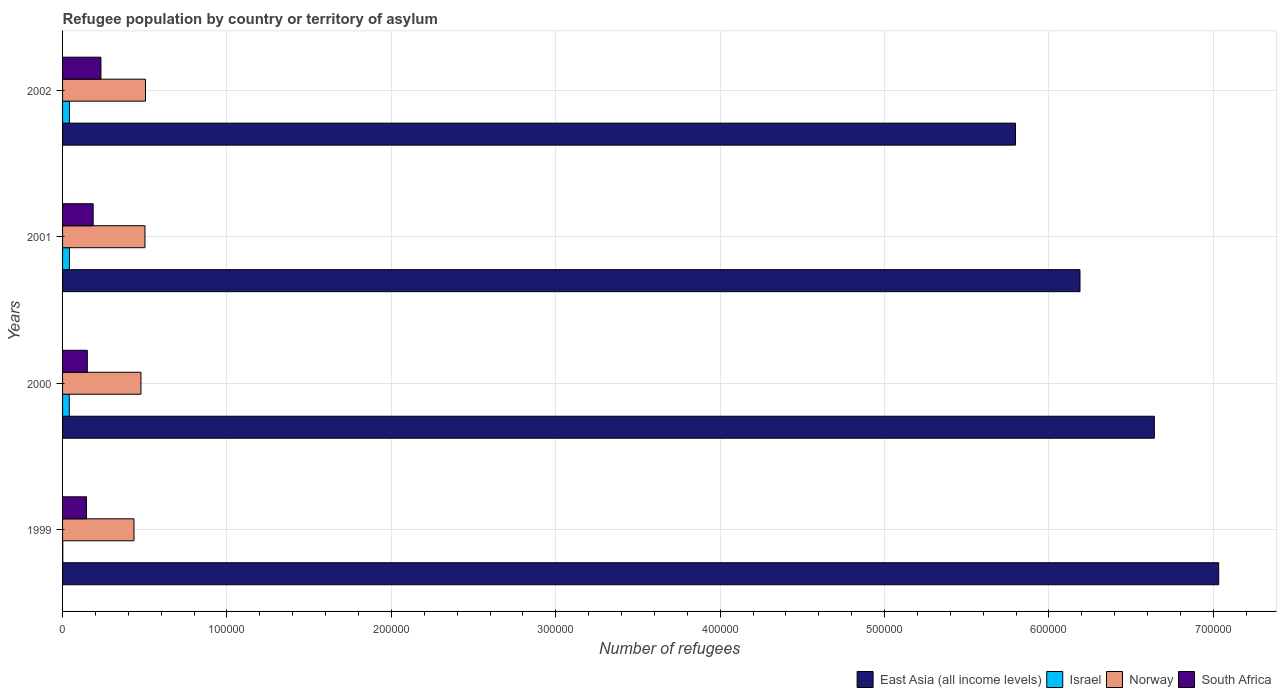How many different coloured bars are there?
Offer a terse response. 4. Are the number of bars per tick equal to the number of legend labels?
Your response must be concise. Yes. Are the number of bars on each tick of the Y-axis equal?
Provide a short and direct response. Yes. How many bars are there on the 1st tick from the top?
Keep it short and to the point. 4. How many bars are there on the 3rd tick from the bottom?
Provide a short and direct response. 4. What is the number of refugees in South Africa in 2000?
Your answer should be very brief. 1.51e+04. Across all years, what is the maximum number of refugees in Norway?
Provide a short and direct response. 5.04e+04. Across all years, what is the minimum number of refugees in East Asia (all income levels)?
Offer a terse response. 5.80e+05. In which year was the number of refugees in Norway maximum?
Ensure brevity in your answer.  2002. What is the total number of refugees in Israel in the graph?
Offer a very short reply. 1.26e+04. What is the difference between the number of refugees in South Africa in 1999 and that in 2001?
Make the answer very short. -4067. What is the difference between the number of refugees in South Africa in 2000 and the number of refugees in East Asia (all income levels) in 2001?
Offer a terse response. -6.04e+05. What is the average number of refugees in South Africa per year?
Your answer should be very brief. 1.79e+04. In the year 1999, what is the difference between the number of refugees in Israel and number of refugees in East Asia (all income levels)?
Your answer should be compact. -7.03e+05. What is the ratio of the number of refugees in Norway in 1999 to that in 2000?
Offer a terse response. 0.91. Is the difference between the number of refugees in Israel in 1999 and 2000 greater than the difference between the number of refugees in East Asia (all income levels) in 1999 and 2000?
Your answer should be compact. No. What is the difference between the highest and the second highest number of refugees in Norway?
Your answer should be very brief. 304. What is the difference between the highest and the lowest number of refugees in East Asia (all income levels)?
Provide a short and direct response. 1.24e+05. In how many years, is the number of refugees in Israel greater than the average number of refugees in Israel taken over all years?
Your answer should be compact. 3. What does the 4th bar from the top in 2001 represents?
Your answer should be compact. East Asia (all income levels). What does the 1st bar from the bottom in 1999 represents?
Keep it short and to the point. East Asia (all income levels). How many bars are there?
Provide a succinct answer. 16. How many years are there in the graph?
Give a very brief answer. 4. What is the difference between two consecutive major ticks on the X-axis?
Provide a succinct answer. 1.00e+05. Are the values on the major ticks of X-axis written in scientific E-notation?
Offer a terse response. No. Does the graph contain any zero values?
Make the answer very short. No. How are the legend labels stacked?
Offer a terse response. Horizontal. What is the title of the graph?
Provide a succinct answer. Refugee population by country or territory of asylum. Does "Syrian Arab Republic" appear as one of the legend labels in the graph?
Your response must be concise. No. What is the label or title of the X-axis?
Your answer should be very brief. Number of refugees. What is the label or title of the Y-axis?
Your answer should be very brief. Years. What is the Number of refugees in East Asia (all income levels) in 1999?
Offer a terse response. 7.03e+05. What is the Number of refugees in Israel in 1999?
Offer a very short reply. 128. What is the Number of refugees in Norway in 1999?
Offer a very short reply. 4.34e+04. What is the Number of refugees in South Africa in 1999?
Offer a very short reply. 1.45e+04. What is the Number of refugees of East Asia (all income levels) in 2000?
Give a very brief answer. 6.64e+05. What is the Number of refugees of Israel in 2000?
Your answer should be very brief. 4075. What is the Number of refugees of Norway in 2000?
Make the answer very short. 4.77e+04. What is the Number of refugees of South Africa in 2000?
Offer a very short reply. 1.51e+04. What is the Number of refugees of East Asia (all income levels) in 2001?
Your response must be concise. 6.19e+05. What is the Number of refugees of Israel in 2001?
Make the answer very short. 4168. What is the Number of refugees of Norway in 2001?
Make the answer very short. 5.01e+04. What is the Number of refugees of South Africa in 2001?
Offer a terse response. 1.86e+04. What is the Number of refugees in East Asia (all income levels) in 2002?
Give a very brief answer. 5.80e+05. What is the Number of refugees in Israel in 2002?
Provide a succinct answer. 4179. What is the Number of refugees in Norway in 2002?
Provide a succinct answer. 5.04e+04. What is the Number of refugees in South Africa in 2002?
Ensure brevity in your answer.  2.33e+04. Across all years, what is the maximum Number of refugees in East Asia (all income levels)?
Provide a short and direct response. 7.03e+05. Across all years, what is the maximum Number of refugees of Israel?
Your answer should be compact. 4179. Across all years, what is the maximum Number of refugees of Norway?
Ensure brevity in your answer.  5.04e+04. Across all years, what is the maximum Number of refugees in South Africa?
Your response must be concise. 2.33e+04. Across all years, what is the minimum Number of refugees of East Asia (all income levels)?
Offer a very short reply. 5.80e+05. Across all years, what is the minimum Number of refugees of Israel?
Make the answer very short. 128. Across all years, what is the minimum Number of refugees in Norway?
Your answer should be compact. 4.34e+04. Across all years, what is the minimum Number of refugees of South Africa?
Offer a very short reply. 1.45e+04. What is the total Number of refugees of East Asia (all income levels) in the graph?
Keep it short and to the point. 2.57e+06. What is the total Number of refugees in Israel in the graph?
Provide a succinct answer. 1.26e+04. What is the total Number of refugees in Norway in the graph?
Your answer should be very brief. 1.92e+05. What is the total Number of refugees of South Africa in the graph?
Your response must be concise. 7.16e+04. What is the difference between the Number of refugees of East Asia (all income levels) in 1999 and that in 2000?
Provide a succinct answer. 3.91e+04. What is the difference between the Number of refugees in Israel in 1999 and that in 2000?
Ensure brevity in your answer.  -3947. What is the difference between the Number of refugees of Norway in 1999 and that in 2000?
Provide a short and direct response. -4253. What is the difference between the Number of refugees of South Africa in 1999 and that in 2000?
Offer a very short reply. -525. What is the difference between the Number of refugees of East Asia (all income levels) in 1999 and that in 2001?
Offer a very short reply. 8.44e+04. What is the difference between the Number of refugees in Israel in 1999 and that in 2001?
Ensure brevity in your answer.  -4040. What is the difference between the Number of refugees in Norway in 1999 and that in 2001?
Your answer should be compact. -6688. What is the difference between the Number of refugees in South Africa in 1999 and that in 2001?
Keep it short and to the point. -4067. What is the difference between the Number of refugees of East Asia (all income levels) in 1999 and that in 2002?
Offer a very short reply. 1.24e+05. What is the difference between the Number of refugees in Israel in 1999 and that in 2002?
Offer a terse response. -4051. What is the difference between the Number of refugees of Norway in 1999 and that in 2002?
Provide a short and direct response. -6992. What is the difference between the Number of refugees in South Africa in 1999 and that in 2002?
Your answer should be compact. -8806. What is the difference between the Number of refugees in East Asia (all income levels) in 2000 and that in 2001?
Keep it short and to the point. 4.52e+04. What is the difference between the Number of refugees of Israel in 2000 and that in 2001?
Offer a terse response. -93. What is the difference between the Number of refugees of Norway in 2000 and that in 2001?
Provide a short and direct response. -2435. What is the difference between the Number of refugees in South Africa in 2000 and that in 2001?
Keep it short and to the point. -3542. What is the difference between the Number of refugees in East Asia (all income levels) in 2000 and that in 2002?
Ensure brevity in your answer.  8.44e+04. What is the difference between the Number of refugees of Israel in 2000 and that in 2002?
Your answer should be compact. -104. What is the difference between the Number of refugees in Norway in 2000 and that in 2002?
Your answer should be compact. -2739. What is the difference between the Number of refugees of South Africa in 2000 and that in 2002?
Provide a succinct answer. -8281. What is the difference between the Number of refugees in East Asia (all income levels) in 2001 and that in 2002?
Provide a short and direct response. 3.92e+04. What is the difference between the Number of refugees of Norway in 2001 and that in 2002?
Make the answer very short. -304. What is the difference between the Number of refugees in South Africa in 2001 and that in 2002?
Make the answer very short. -4739. What is the difference between the Number of refugees in East Asia (all income levels) in 1999 and the Number of refugees in Israel in 2000?
Keep it short and to the point. 6.99e+05. What is the difference between the Number of refugees in East Asia (all income levels) in 1999 and the Number of refugees in Norway in 2000?
Make the answer very short. 6.56e+05. What is the difference between the Number of refugees in East Asia (all income levels) in 1999 and the Number of refugees in South Africa in 2000?
Give a very brief answer. 6.88e+05. What is the difference between the Number of refugees in Israel in 1999 and the Number of refugees in Norway in 2000?
Provide a succinct answer. -4.76e+04. What is the difference between the Number of refugees of Israel in 1999 and the Number of refugees of South Africa in 2000?
Make the answer very short. -1.49e+04. What is the difference between the Number of refugees in Norway in 1999 and the Number of refugees in South Africa in 2000?
Provide a short and direct response. 2.84e+04. What is the difference between the Number of refugees of East Asia (all income levels) in 1999 and the Number of refugees of Israel in 2001?
Provide a succinct answer. 6.99e+05. What is the difference between the Number of refugees in East Asia (all income levels) in 1999 and the Number of refugees in Norway in 2001?
Your answer should be compact. 6.53e+05. What is the difference between the Number of refugees in East Asia (all income levels) in 1999 and the Number of refugees in South Africa in 2001?
Provide a succinct answer. 6.85e+05. What is the difference between the Number of refugees in Israel in 1999 and the Number of refugees in Norway in 2001?
Ensure brevity in your answer.  -5.00e+04. What is the difference between the Number of refugees in Israel in 1999 and the Number of refugees in South Africa in 2001?
Your answer should be very brief. -1.85e+04. What is the difference between the Number of refugees in Norway in 1999 and the Number of refugees in South Africa in 2001?
Keep it short and to the point. 2.48e+04. What is the difference between the Number of refugees of East Asia (all income levels) in 1999 and the Number of refugees of Israel in 2002?
Keep it short and to the point. 6.99e+05. What is the difference between the Number of refugees of East Asia (all income levels) in 1999 and the Number of refugees of Norway in 2002?
Provide a short and direct response. 6.53e+05. What is the difference between the Number of refugees in East Asia (all income levels) in 1999 and the Number of refugees in South Africa in 2002?
Give a very brief answer. 6.80e+05. What is the difference between the Number of refugees in Israel in 1999 and the Number of refugees in Norway in 2002?
Make the answer very short. -5.03e+04. What is the difference between the Number of refugees of Israel in 1999 and the Number of refugees of South Africa in 2002?
Make the answer very short. -2.32e+04. What is the difference between the Number of refugees of Norway in 1999 and the Number of refugees of South Africa in 2002?
Give a very brief answer. 2.01e+04. What is the difference between the Number of refugees in East Asia (all income levels) in 2000 and the Number of refugees in Israel in 2001?
Give a very brief answer. 6.60e+05. What is the difference between the Number of refugees of East Asia (all income levels) in 2000 and the Number of refugees of Norway in 2001?
Your answer should be very brief. 6.14e+05. What is the difference between the Number of refugees in East Asia (all income levels) in 2000 and the Number of refugees in South Africa in 2001?
Give a very brief answer. 6.46e+05. What is the difference between the Number of refugees of Israel in 2000 and the Number of refugees of Norway in 2001?
Your answer should be compact. -4.61e+04. What is the difference between the Number of refugees of Israel in 2000 and the Number of refugees of South Africa in 2001?
Provide a succinct answer. -1.45e+04. What is the difference between the Number of refugees in Norway in 2000 and the Number of refugees in South Africa in 2001?
Offer a very short reply. 2.91e+04. What is the difference between the Number of refugees in East Asia (all income levels) in 2000 and the Number of refugees in Israel in 2002?
Provide a short and direct response. 6.60e+05. What is the difference between the Number of refugees in East Asia (all income levels) in 2000 and the Number of refugees in Norway in 2002?
Ensure brevity in your answer.  6.14e+05. What is the difference between the Number of refugees of East Asia (all income levels) in 2000 and the Number of refugees of South Africa in 2002?
Your response must be concise. 6.41e+05. What is the difference between the Number of refugees of Israel in 2000 and the Number of refugees of Norway in 2002?
Offer a terse response. -4.64e+04. What is the difference between the Number of refugees in Israel in 2000 and the Number of refugees in South Africa in 2002?
Provide a short and direct response. -1.93e+04. What is the difference between the Number of refugees in Norway in 2000 and the Number of refugees in South Africa in 2002?
Your answer should be compact. 2.43e+04. What is the difference between the Number of refugees in East Asia (all income levels) in 2001 and the Number of refugees in Israel in 2002?
Ensure brevity in your answer.  6.15e+05. What is the difference between the Number of refugees in East Asia (all income levels) in 2001 and the Number of refugees in Norway in 2002?
Your answer should be very brief. 5.68e+05. What is the difference between the Number of refugees in East Asia (all income levels) in 2001 and the Number of refugees in South Africa in 2002?
Provide a succinct answer. 5.96e+05. What is the difference between the Number of refugees of Israel in 2001 and the Number of refugees of Norway in 2002?
Make the answer very short. -4.63e+04. What is the difference between the Number of refugees in Israel in 2001 and the Number of refugees in South Africa in 2002?
Offer a very short reply. -1.92e+04. What is the difference between the Number of refugees of Norway in 2001 and the Number of refugees of South Africa in 2002?
Your answer should be compact. 2.68e+04. What is the average Number of refugees of East Asia (all income levels) per year?
Provide a short and direct response. 6.41e+05. What is the average Number of refugees of Israel per year?
Offer a terse response. 3137.5. What is the average Number of refugees of Norway per year?
Your answer should be very brief. 4.79e+04. What is the average Number of refugees of South Africa per year?
Make the answer very short. 1.79e+04. In the year 1999, what is the difference between the Number of refugees of East Asia (all income levels) and Number of refugees of Israel?
Your response must be concise. 7.03e+05. In the year 1999, what is the difference between the Number of refugees of East Asia (all income levels) and Number of refugees of Norway?
Make the answer very short. 6.60e+05. In the year 1999, what is the difference between the Number of refugees of East Asia (all income levels) and Number of refugees of South Africa?
Give a very brief answer. 6.89e+05. In the year 1999, what is the difference between the Number of refugees of Israel and Number of refugees of Norway?
Make the answer very short. -4.33e+04. In the year 1999, what is the difference between the Number of refugees in Israel and Number of refugees in South Africa?
Offer a very short reply. -1.44e+04. In the year 1999, what is the difference between the Number of refugees in Norway and Number of refugees in South Africa?
Give a very brief answer. 2.89e+04. In the year 2000, what is the difference between the Number of refugees in East Asia (all income levels) and Number of refugees in Israel?
Ensure brevity in your answer.  6.60e+05. In the year 2000, what is the difference between the Number of refugees in East Asia (all income levels) and Number of refugees in Norway?
Keep it short and to the point. 6.16e+05. In the year 2000, what is the difference between the Number of refugees in East Asia (all income levels) and Number of refugees in South Africa?
Give a very brief answer. 6.49e+05. In the year 2000, what is the difference between the Number of refugees in Israel and Number of refugees in Norway?
Your answer should be compact. -4.36e+04. In the year 2000, what is the difference between the Number of refugees of Israel and Number of refugees of South Africa?
Your answer should be very brief. -1.10e+04. In the year 2000, what is the difference between the Number of refugees in Norway and Number of refugees in South Africa?
Offer a very short reply. 3.26e+04. In the year 2001, what is the difference between the Number of refugees of East Asia (all income levels) and Number of refugees of Israel?
Make the answer very short. 6.15e+05. In the year 2001, what is the difference between the Number of refugees in East Asia (all income levels) and Number of refugees in Norway?
Offer a very short reply. 5.69e+05. In the year 2001, what is the difference between the Number of refugees in East Asia (all income levels) and Number of refugees in South Africa?
Provide a short and direct response. 6.00e+05. In the year 2001, what is the difference between the Number of refugees of Israel and Number of refugees of Norway?
Your answer should be compact. -4.60e+04. In the year 2001, what is the difference between the Number of refugees in Israel and Number of refugees in South Africa?
Offer a very short reply. -1.44e+04. In the year 2001, what is the difference between the Number of refugees of Norway and Number of refugees of South Africa?
Make the answer very short. 3.15e+04. In the year 2002, what is the difference between the Number of refugees in East Asia (all income levels) and Number of refugees in Israel?
Offer a terse response. 5.75e+05. In the year 2002, what is the difference between the Number of refugees in East Asia (all income levels) and Number of refugees in Norway?
Offer a very short reply. 5.29e+05. In the year 2002, what is the difference between the Number of refugees of East Asia (all income levels) and Number of refugees of South Africa?
Provide a succinct answer. 5.56e+05. In the year 2002, what is the difference between the Number of refugees of Israel and Number of refugees of Norway?
Keep it short and to the point. -4.63e+04. In the year 2002, what is the difference between the Number of refugees in Israel and Number of refugees in South Africa?
Offer a terse response. -1.92e+04. In the year 2002, what is the difference between the Number of refugees of Norway and Number of refugees of South Africa?
Provide a short and direct response. 2.71e+04. What is the ratio of the Number of refugees of East Asia (all income levels) in 1999 to that in 2000?
Provide a short and direct response. 1.06. What is the ratio of the Number of refugees of Israel in 1999 to that in 2000?
Ensure brevity in your answer.  0.03. What is the ratio of the Number of refugees in Norway in 1999 to that in 2000?
Offer a very short reply. 0.91. What is the ratio of the Number of refugees of South Africa in 1999 to that in 2000?
Your answer should be compact. 0.97. What is the ratio of the Number of refugees of East Asia (all income levels) in 1999 to that in 2001?
Give a very brief answer. 1.14. What is the ratio of the Number of refugees of Israel in 1999 to that in 2001?
Make the answer very short. 0.03. What is the ratio of the Number of refugees in Norway in 1999 to that in 2001?
Your answer should be compact. 0.87. What is the ratio of the Number of refugees of South Africa in 1999 to that in 2001?
Your response must be concise. 0.78. What is the ratio of the Number of refugees of East Asia (all income levels) in 1999 to that in 2002?
Give a very brief answer. 1.21. What is the ratio of the Number of refugees in Israel in 1999 to that in 2002?
Ensure brevity in your answer.  0.03. What is the ratio of the Number of refugees of Norway in 1999 to that in 2002?
Offer a very short reply. 0.86. What is the ratio of the Number of refugees in South Africa in 1999 to that in 2002?
Ensure brevity in your answer.  0.62. What is the ratio of the Number of refugees of East Asia (all income levels) in 2000 to that in 2001?
Your response must be concise. 1.07. What is the ratio of the Number of refugees in Israel in 2000 to that in 2001?
Provide a short and direct response. 0.98. What is the ratio of the Number of refugees of Norway in 2000 to that in 2001?
Offer a terse response. 0.95. What is the ratio of the Number of refugees of South Africa in 2000 to that in 2001?
Make the answer very short. 0.81. What is the ratio of the Number of refugees of East Asia (all income levels) in 2000 to that in 2002?
Your answer should be very brief. 1.15. What is the ratio of the Number of refugees in Israel in 2000 to that in 2002?
Ensure brevity in your answer.  0.98. What is the ratio of the Number of refugees of Norway in 2000 to that in 2002?
Provide a succinct answer. 0.95. What is the ratio of the Number of refugees of South Africa in 2000 to that in 2002?
Give a very brief answer. 0.65. What is the ratio of the Number of refugees in East Asia (all income levels) in 2001 to that in 2002?
Give a very brief answer. 1.07. What is the ratio of the Number of refugees in South Africa in 2001 to that in 2002?
Your answer should be compact. 0.8. What is the difference between the highest and the second highest Number of refugees of East Asia (all income levels)?
Provide a succinct answer. 3.91e+04. What is the difference between the highest and the second highest Number of refugees of Israel?
Offer a very short reply. 11. What is the difference between the highest and the second highest Number of refugees of Norway?
Your response must be concise. 304. What is the difference between the highest and the second highest Number of refugees of South Africa?
Provide a short and direct response. 4739. What is the difference between the highest and the lowest Number of refugees of East Asia (all income levels)?
Provide a short and direct response. 1.24e+05. What is the difference between the highest and the lowest Number of refugees in Israel?
Provide a short and direct response. 4051. What is the difference between the highest and the lowest Number of refugees of Norway?
Ensure brevity in your answer.  6992. What is the difference between the highest and the lowest Number of refugees of South Africa?
Keep it short and to the point. 8806. 